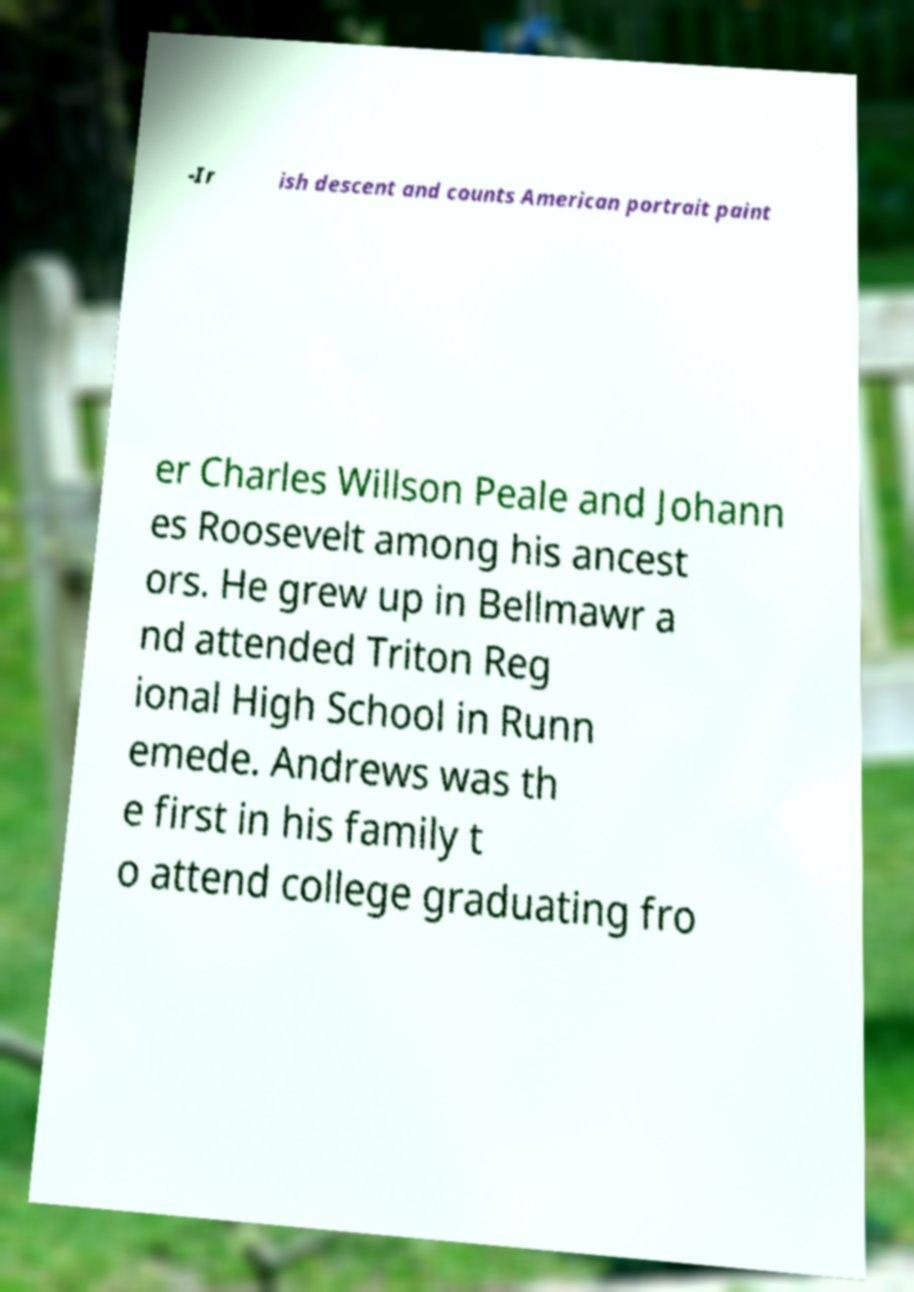For documentation purposes, I need the text within this image transcribed. Could you provide that? -Ir ish descent and counts American portrait paint er Charles Willson Peale and Johann es Roosevelt among his ancest ors. He grew up in Bellmawr a nd attended Triton Reg ional High School in Runn emede. Andrews was th e first in his family t o attend college graduating fro 